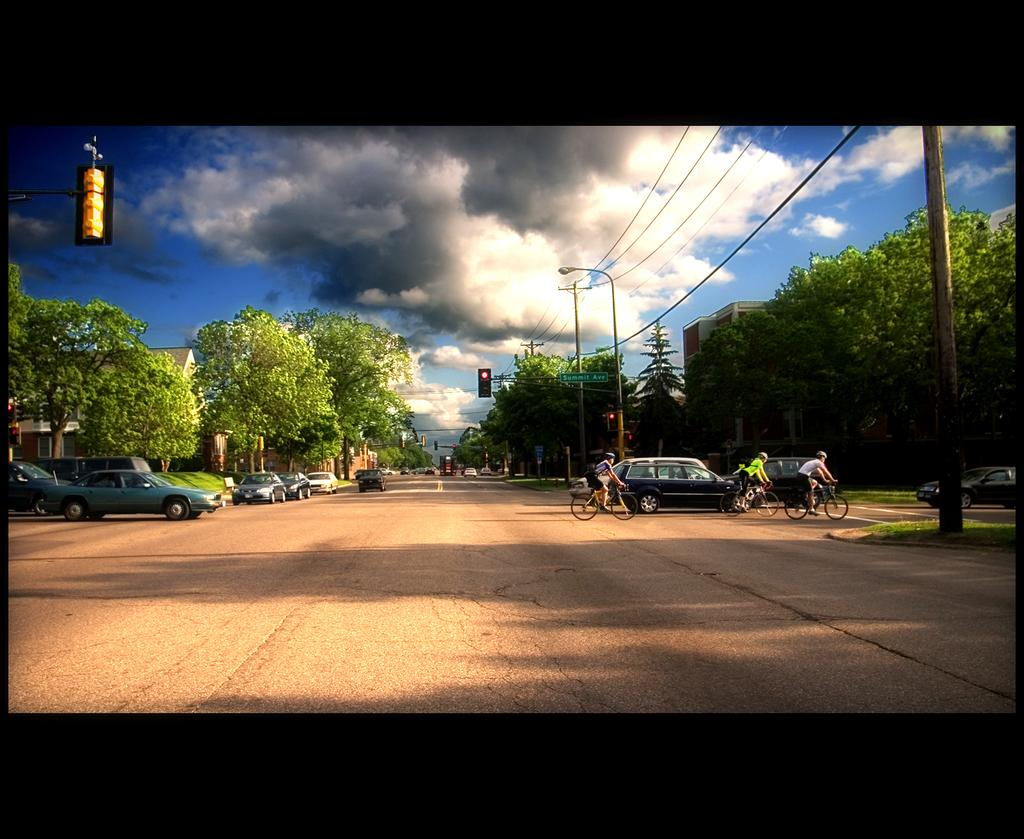What types of transportation are present in the image? There are vehicles in the image. What are the persons in the image using for transportation? The persons in the image are riding bicycles. What type of vegetation can be seen in the image? There are trees in the image. What are the poles used for in the image? The purpose of the poles is not specified in the image. What is the ground covered with in the image? The ground is covered with grass in the image. What is the condition of the sky in the image? The sky is cloudy in the image. What type of shoes can be seen on the trees in the image? There are no shoes present on the trees in the image. What kind of toy is being played with by the persons riding bicycles in the image? There are no toys visible in the image; the persons are riding bicycles. 